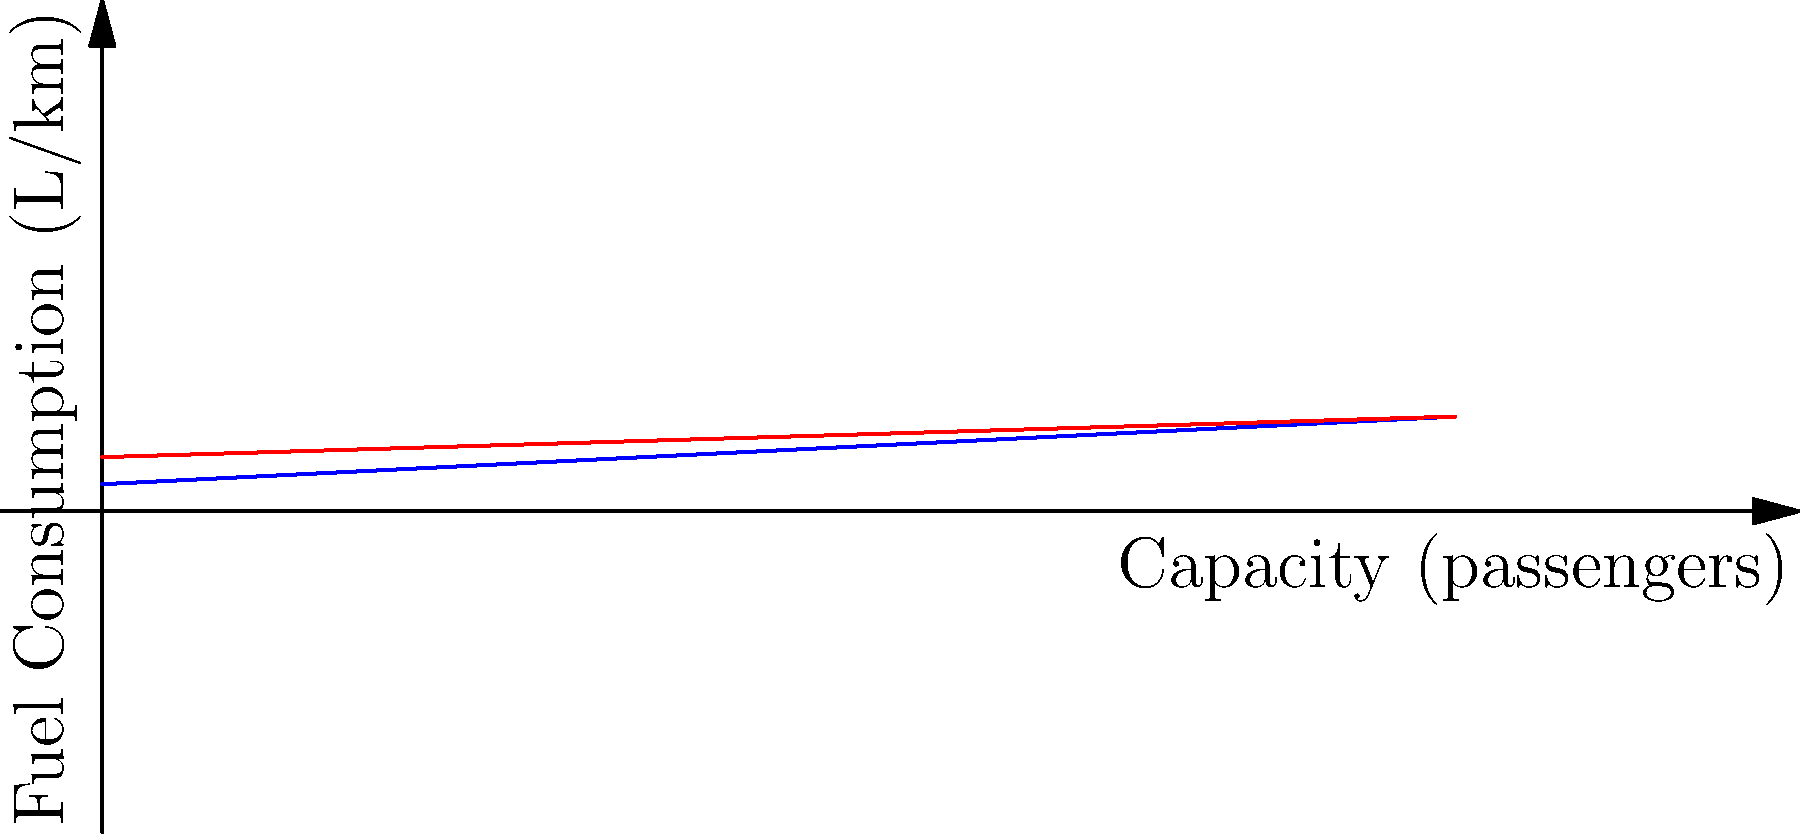Based on the graph showing the relationship between passenger capacity and fuel consumption for buses and light rail systems, calculate the percentage difference in fuel efficiency (passengers per liter per km) between a bus and a light rail train when both are operating at full capacity of 100 passengers. Which mode of transportation is more fuel-efficient at this capacity? Let's approach this step-by-step:

1) First, we need to determine the fuel consumption for each vehicle at 100 passengers:

   Bus: $f_b(100) = 0.05 * 100 + 2 = 7$ L/km
   Light Rail: $f_l(100) = 0.03 * 100 + 4 = 7$ L/km

2) Now, let's calculate the fuel efficiency (passengers per liter per km) for each:

   Bus: $E_b = \frac{100}{7} \approx 14.29$ passengers/L/km
   Light Rail: $E_l = \frac{100}{7} \approx 14.29$ passengers/L/km

3) To calculate the percentage difference, we use the formula:

   $\text{Percentage Difference} = \frac{|E_b - E_l|}{\frac{E_b + E_l}{2}} * 100\%$

4) Plugging in our values:

   $\text{Percentage Difference} = \frac{|14.29 - 14.29|}{\frac{14.29 + 14.29}{2}} * 100\% = 0\%$

5) The percentage difference is 0%, meaning there is no difference in fuel efficiency between the bus and light rail at 100 passengers.

Therefore, at full capacity of 100 passengers, both the bus and light rail have the same fuel efficiency.
Answer: 0% difference; both equally fuel-efficient at 100 passengers. 